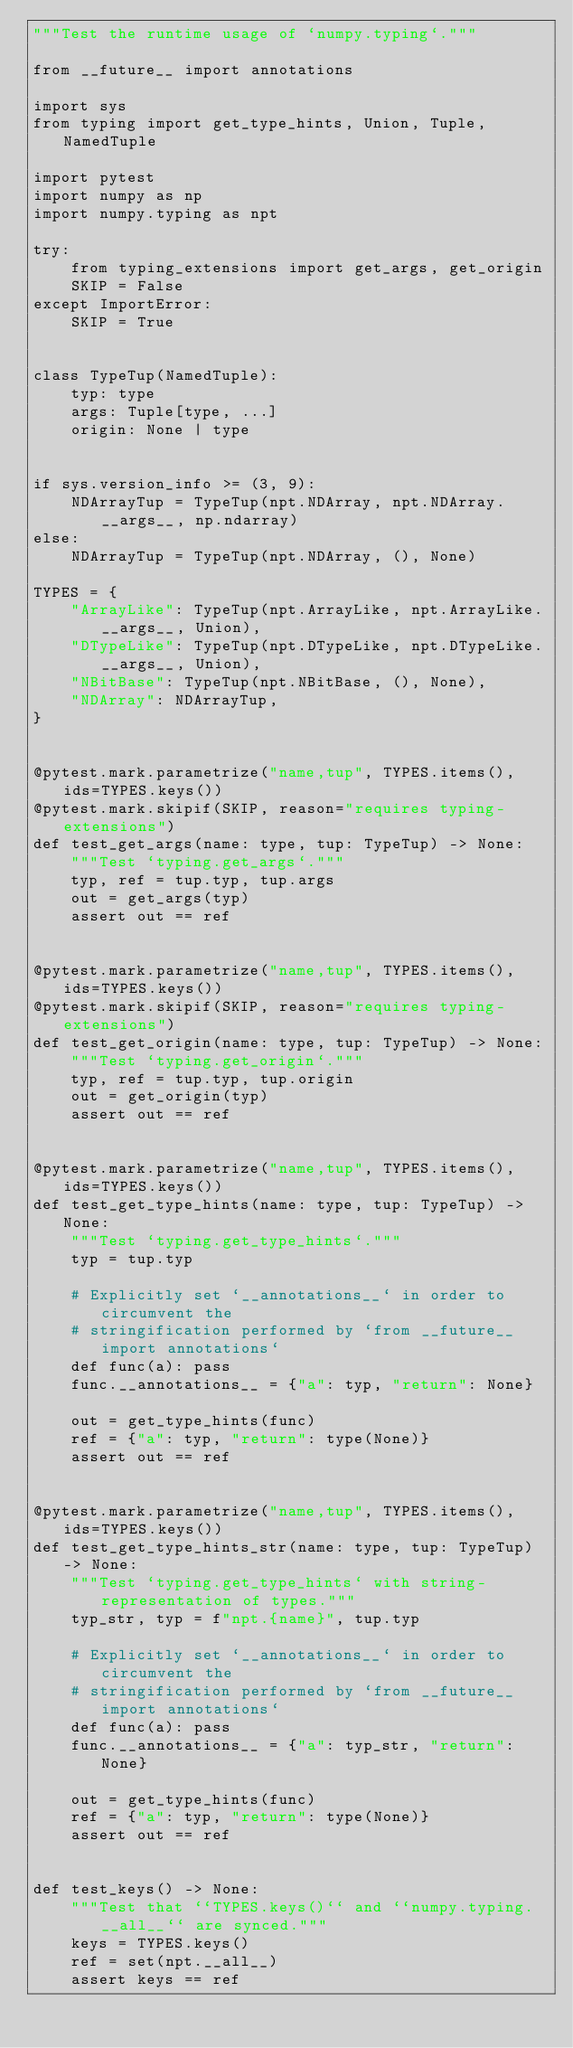Convert code to text. <code><loc_0><loc_0><loc_500><loc_500><_Python_>"""Test the runtime usage of `numpy.typing`."""

from __future__ import annotations

import sys
from typing import get_type_hints, Union, Tuple, NamedTuple

import pytest
import numpy as np
import numpy.typing as npt

try:
    from typing_extensions import get_args, get_origin
    SKIP = False
except ImportError:
    SKIP = True


class TypeTup(NamedTuple):
    typ: type
    args: Tuple[type, ...]
    origin: None | type


if sys.version_info >= (3, 9):
    NDArrayTup = TypeTup(npt.NDArray, npt.NDArray.__args__, np.ndarray)
else:
    NDArrayTup = TypeTup(npt.NDArray, (), None)

TYPES = {
    "ArrayLike": TypeTup(npt.ArrayLike, npt.ArrayLike.__args__, Union),
    "DTypeLike": TypeTup(npt.DTypeLike, npt.DTypeLike.__args__, Union),
    "NBitBase": TypeTup(npt.NBitBase, (), None),
    "NDArray": NDArrayTup,
}


@pytest.mark.parametrize("name,tup", TYPES.items(), ids=TYPES.keys())
@pytest.mark.skipif(SKIP, reason="requires typing-extensions")
def test_get_args(name: type, tup: TypeTup) -> None:
    """Test `typing.get_args`."""
    typ, ref = tup.typ, tup.args
    out = get_args(typ)
    assert out == ref


@pytest.mark.parametrize("name,tup", TYPES.items(), ids=TYPES.keys())
@pytest.mark.skipif(SKIP, reason="requires typing-extensions")
def test_get_origin(name: type, tup: TypeTup) -> None:
    """Test `typing.get_origin`."""
    typ, ref = tup.typ, tup.origin
    out = get_origin(typ)
    assert out == ref


@pytest.mark.parametrize("name,tup", TYPES.items(), ids=TYPES.keys())
def test_get_type_hints(name: type, tup: TypeTup) -> None:
    """Test `typing.get_type_hints`."""
    typ = tup.typ

    # Explicitly set `__annotations__` in order to circumvent the
    # stringification performed by `from __future__ import annotations`
    def func(a): pass
    func.__annotations__ = {"a": typ, "return": None}

    out = get_type_hints(func)
    ref = {"a": typ, "return": type(None)}
    assert out == ref


@pytest.mark.parametrize("name,tup", TYPES.items(), ids=TYPES.keys())
def test_get_type_hints_str(name: type, tup: TypeTup) -> None:
    """Test `typing.get_type_hints` with string-representation of types."""
    typ_str, typ = f"npt.{name}", tup.typ

    # Explicitly set `__annotations__` in order to circumvent the
    # stringification performed by `from __future__ import annotations`
    def func(a): pass
    func.__annotations__ = {"a": typ_str, "return": None}

    out = get_type_hints(func)
    ref = {"a": typ, "return": type(None)}
    assert out == ref


def test_keys() -> None:
    """Test that ``TYPES.keys()`` and ``numpy.typing.__all__`` are synced."""
    keys = TYPES.keys()
    ref = set(npt.__all__)
    assert keys == ref
</code> 